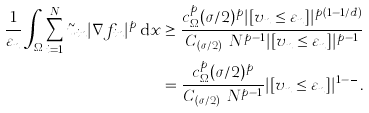Convert formula to latex. <formula><loc_0><loc_0><loc_500><loc_500>\frac { 1 } { \varepsilon _ { n } } \int _ { \Omega } \sum _ { i = 1 } ^ { N } \tilde { u } _ { i n } | \nabla f _ { i n } | ^ { p } \, \mathrm d x & \geq \frac { c _ { \Omega } ^ { p } ( \sigma / 2 ) ^ { p } | [ v _ { n } \leq \varepsilon _ { n } ] | ^ { p ( 1 - 1 / d ) } } { C _ { ( \sigma / 2 ) ^ { p } } N ^ { p - 1 } | [ v _ { n } \leq \varepsilon _ { n } ] | ^ { p - 1 } } \\ & = \frac { c _ { \Omega } ^ { p } ( \sigma / 2 ) ^ { p } } { C _ { ( \sigma / 2 ) ^ { p } } N ^ { p - 1 } } | [ v _ { n } \leq \varepsilon _ { n } ] | ^ { 1 - \frac { p } { d } } .</formula> 